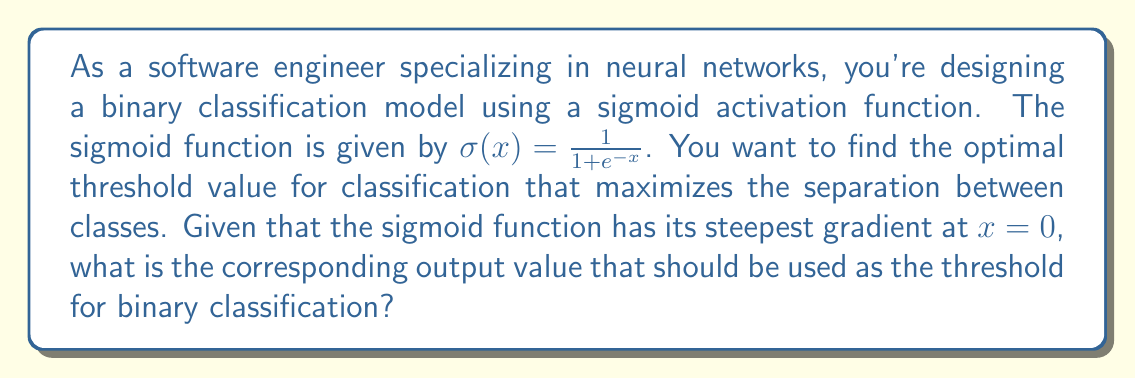Solve this math problem. To solve this problem, we need to follow these steps:

1) Recall the sigmoid function: $\sigma(x) = \frac{1}{1 + e^{-x}}$

2) We're told that the steepest gradient occurs at $x = 0$. This is the point where the function is most sensitive to changes in input, making it an ideal threshold for classification.

3) To find the output value at $x = 0$, we substitute $x = 0$ into the sigmoid function:

   $\sigma(0) = \frac{1}{1 + e^{-0}}$

4) Simplify:
   $e^{-0} = 1$, so:
   
   $\sigma(0) = \frac{1}{1 + 1} = \frac{1}{2}$

5) Therefore, when the input to the sigmoid function is 0, the output is 0.5.

This means that 0.5 is the optimal threshold value for binary classification using a sigmoid activation function. If the output of the sigmoid function is greater than 0.5, we classify it as one class, and if it's less than 0.5, we classify it as the other class.

This threshold provides maximum separation between classes because it's at the point where the sigmoid function has its steepest gradient, making it most sensitive to small changes in input.
Answer: The optimal threshold value for binary classification using a sigmoid activation function is 0.5. 